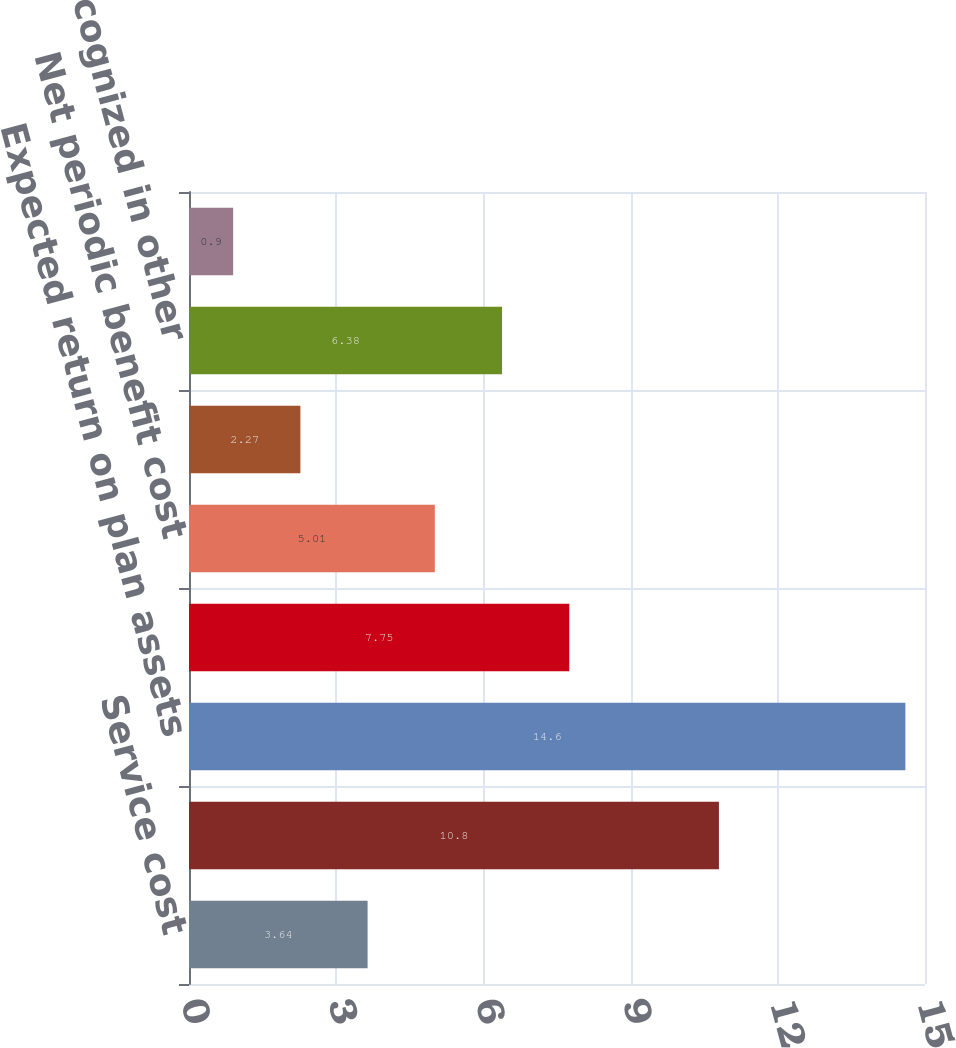Convert chart to OTSL. <chart><loc_0><loc_0><loc_500><loc_500><bar_chart><fcel>Service cost<fcel>Interest cost on benefit<fcel>Expected return on plan assets<fcel>Amortization of net loss<fcel>Net periodic benefit cost<fcel>Net loss incurred<fcel>Total recognized in other<fcel>Total recognized in net<nl><fcel>3.64<fcel>10.8<fcel>14.6<fcel>7.75<fcel>5.01<fcel>2.27<fcel>6.38<fcel>0.9<nl></chart> 